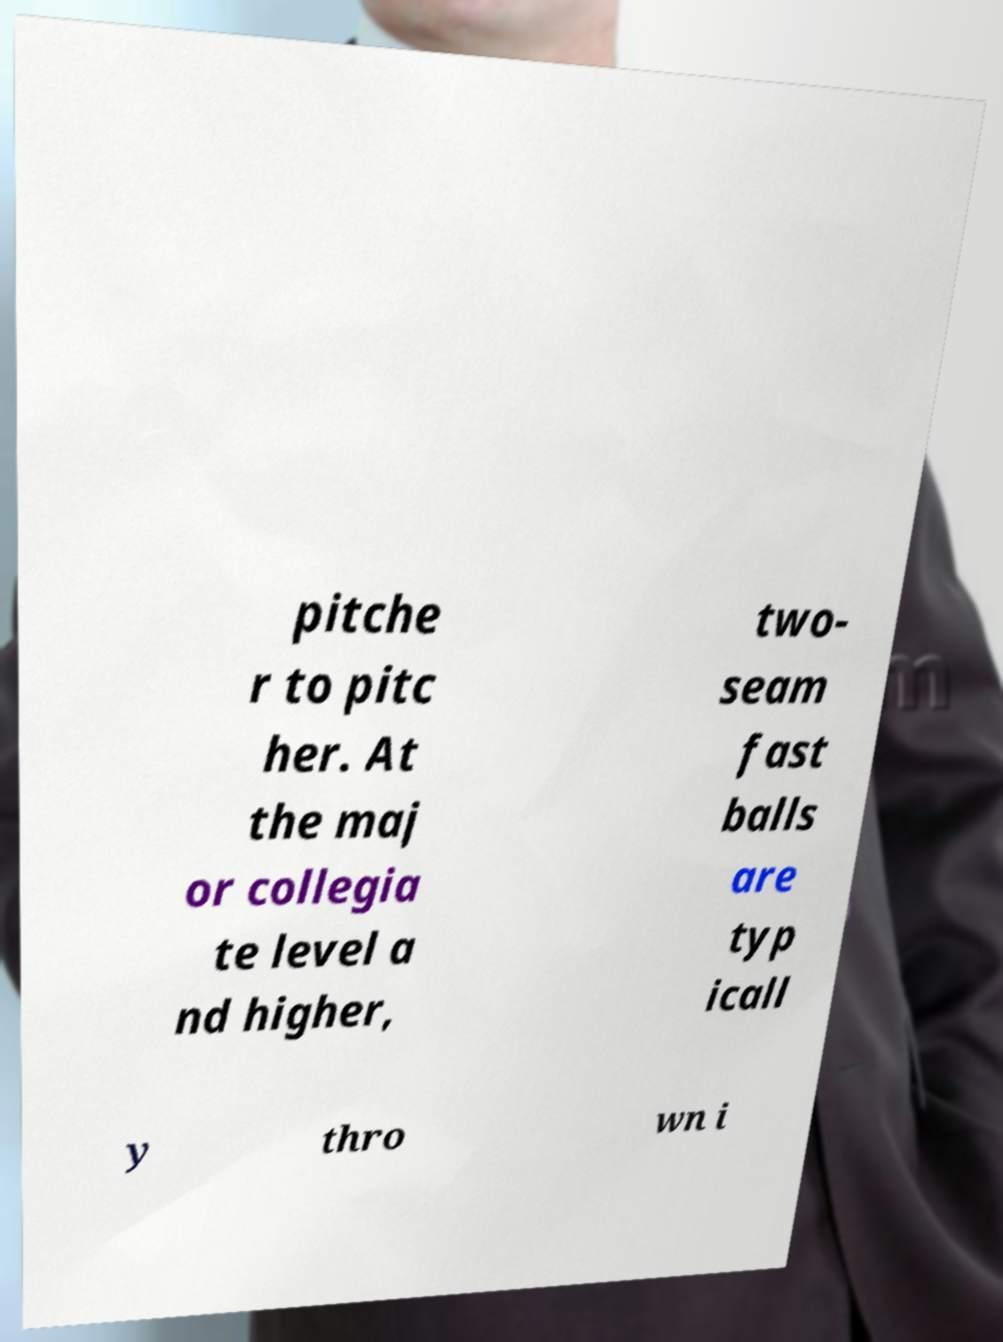Please identify and transcribe the text found in this image. pitche r to pitc her. At the maj or collegia te level a nd higher, two- seam fast balls are typ icall y thro wn i 